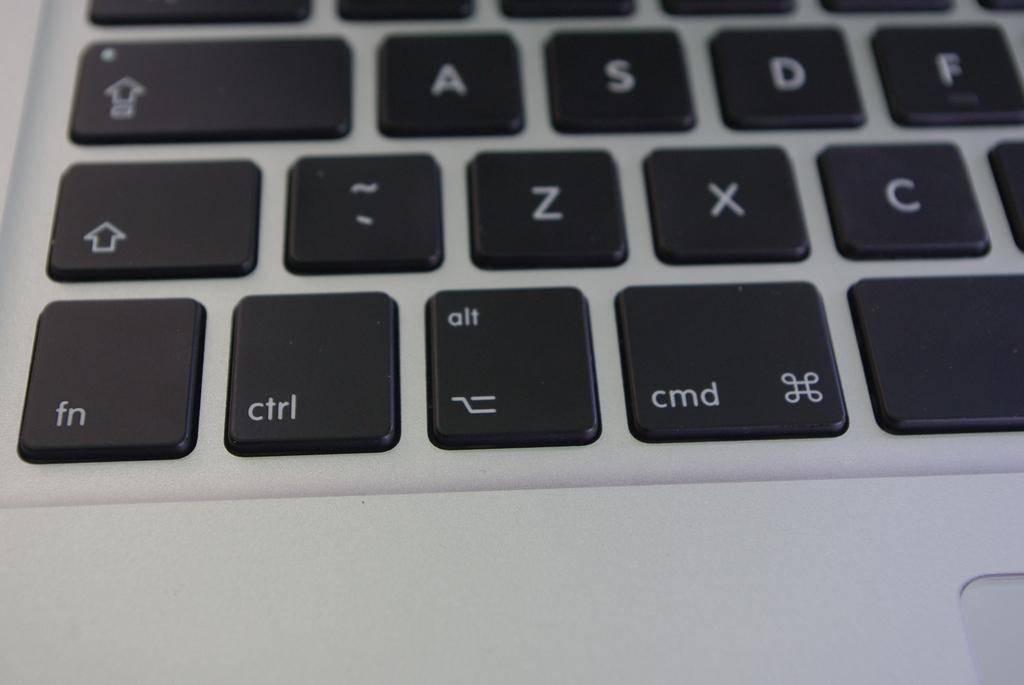<image>
Render a clear and concise summary of the photo. Some black keys on a silver laptop, including fn, ctrl, and cmd. 